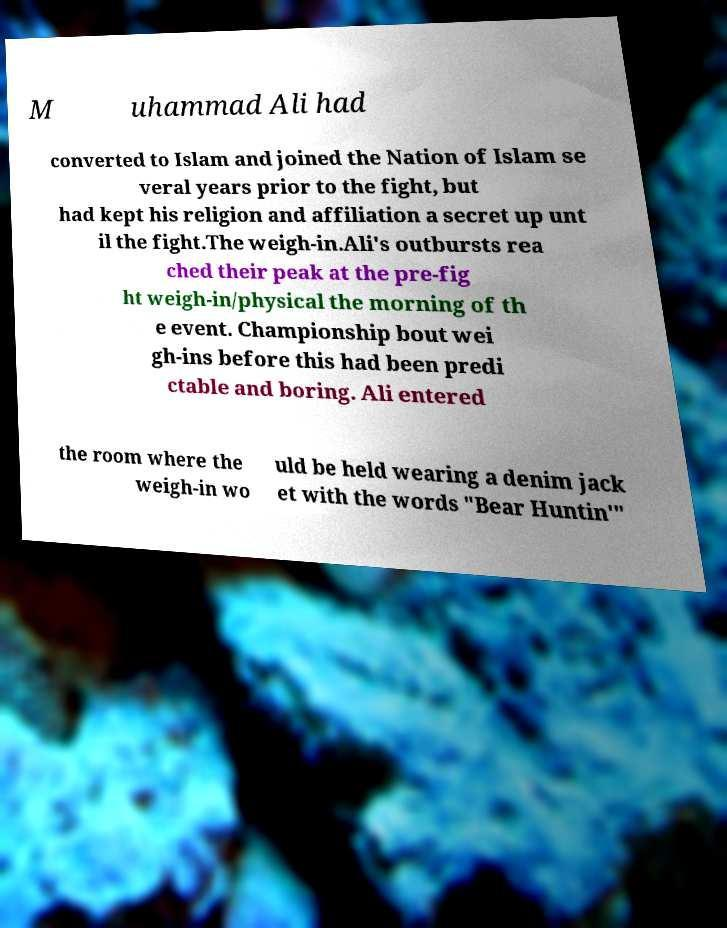Can you accurately transcribe the text from the provided image for me? M uhammad Ali had converted to Islam and joined the Nation of Islam se veral years prior to the fight, but had kept his religion and affiliation a secret up unt il the fight.The weigh-in.Ali's outbursts rea ched their peak at the pre-fig ht weigh-in/physical the morning of th e event. Championship bout wei gh-ins before this had been predi ctable and boring. Ali entered the room where the weigh-in wo uld be held wearing a denim jack et with the words "Bear Huntin'" 